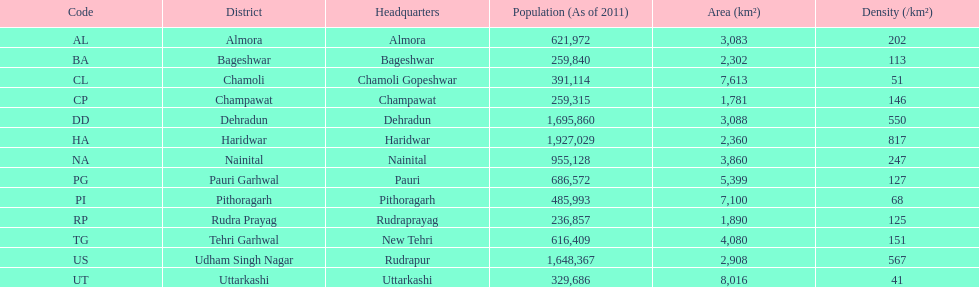What is the total amount of districts listed? 13. 